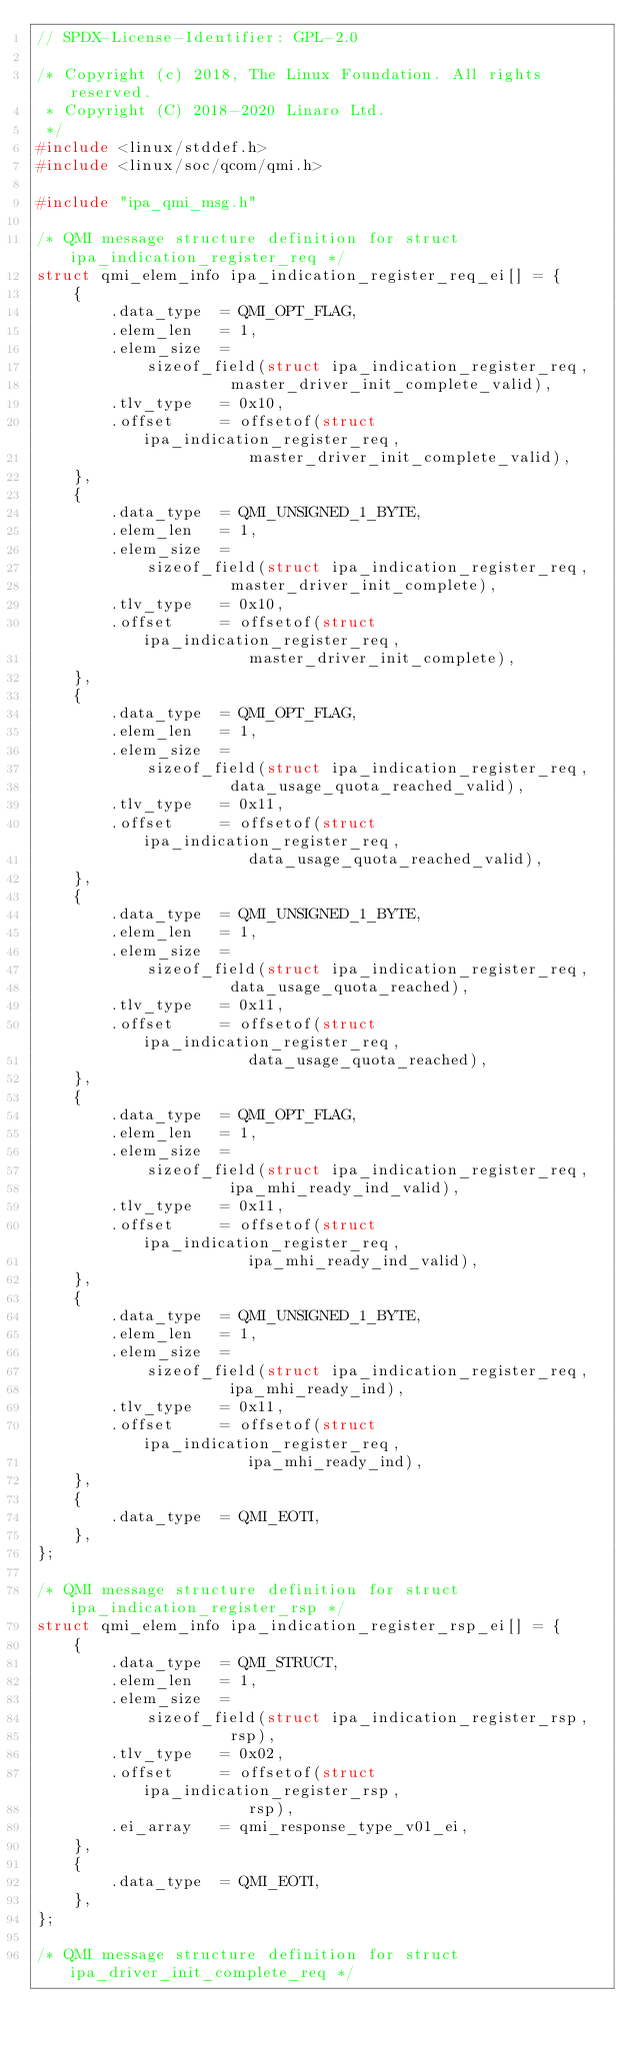<code> <loc_0><loc_0><loc_500><loc_500><_C_>// SPDX-License-Identifier: GPL-2.0

/* Copyright (c) 2018, The Linux Foundation. All rights reserved.
 * Copyright (C) 2018-2020 Linaro Ltd.
 */
#include <linux/stddef.h>
#include <linux/soc/qcom/qmi.h>

#include "ipa_qmi_msg.h"

/* QMI message structure definition for struct ipa_indication_register_req */
struct qmi_elem_info ipa_indication_register_req_ei[] = {
	{
		.data_type	= QMI_OPT_FLAG,
		.elem_len	= 1,
		.elem_size	=
			sizeof_field(struct ipa_indication_register_req,
				     master_driver_init_complete_valid),
		.tlv_type	= 0x10,
		.offset		= offsetof(struct ipa_indication_register_req,
					   master_driver_init_complete_valid),
	},
	{
		.data_type	= QMI_UNSIGNED_1_BYTE,
		.elem_len	= 1,
		.elem_size	=
			sizeof_field(struct ipa_indication_register_req,
				     master_driver_init_complete),
		.tlv_type	= 0x10,
		.offset		= offsetof(struct ipa_indication_register_req,
					   master_driver_init_complete),
	},
	{
		.data_type	= QMI_OPT_FLAG,
		.elem_len	= 1,
		.elem_size	=
			sizeof_field(struct ipa_indication_register_req,
				     data_usage_quota_reached_valid),
		.tlv_type	= 0x11,
		.offset		= offsetof(struct ipa_indication_register_req,
					   data_usage_quota_reached_valid),
	},
	{
		.data_type	= QMI_UNSIGNED_1_BYTE,
		.elem_len	= 1,
		.elem_size	=
			sizeof_field(struct ipa_indication_register_req,
				     data_usage_quota_reached),
		.tlv_type	= 0x11,
		.offset		= offsetof(struct ipa_indication_register_req,
					   data_usage_quota_reached),
	},
	{
		.data_type	= QMI_OPT_FLAG,
		.elem_len	= 1,
		.elem_size	=
			sizeof_field(struct ipa_indication_register_req,
				     ipa_mhi_ready_ind_valid),
		.tlv_type	= 0x11,
		.offset		= offsetof(struct ipa_indication_register_req,
					   ipa_mhi_ready_ind_valid),
	},
	{
		.data_type	= QMI_UNSIGNED_1_BYTE,
		.elem_len	= 1,
		.elem_size	=
			sizeof_field(struct ipa_indication_register_req,
				     ipa_mhi_ready_ind),
		.tlv_type	= 0x11,
		.offset		= offsetof(struct ipa_indication_register_req,
					   ipa_mhi_ready_ind),
	},
	{
		.data_type	= QMI_EOTI,
	},
};

/* QMI message structure definition for struct ipa_indication_register_rsp */
struct qmi_elem_info ipa_indication_register_rsp_ei[] = {
	{
		.data_type	= QMI_STRUCT,
		.elem_len	= 1,
		.elem_size	=
			sizeof_field(struct ipa_indication_register_rsp,
				     rsp),
		.tlv_type	= 0x02,
		.offset		= offsetof(struct ipa_indication_register_rsp,
					   rsp),
		.ei_array	= qmi_response_type_v01_ei,
	},
	{
		.data_type	= QMI_EOTI,
	},
};

/* QMI message structure definition for struct ipa_driver_init_complete_req */</code> 